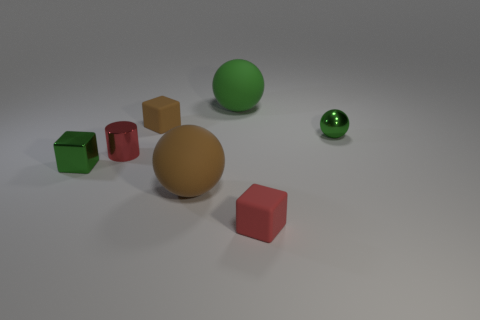What number of other objects are there of the same color as the shiny cube? Apart from the shiny cube, there are two additional objects that share its vibrant green color: a matte sphere and another smaller, glossier sphere. 